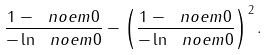<formula> <loc_0><loc_0><loc_500><loc_500>\frac { 1 - \ n o e m { 0 } } { - \ln \ n o e m { 0 } } - \left ( \frac { 1 - \ n o e m { 0 } } { - \ln \ n o e m { 0 } } \right ) ^ { 2 } .</formula> 